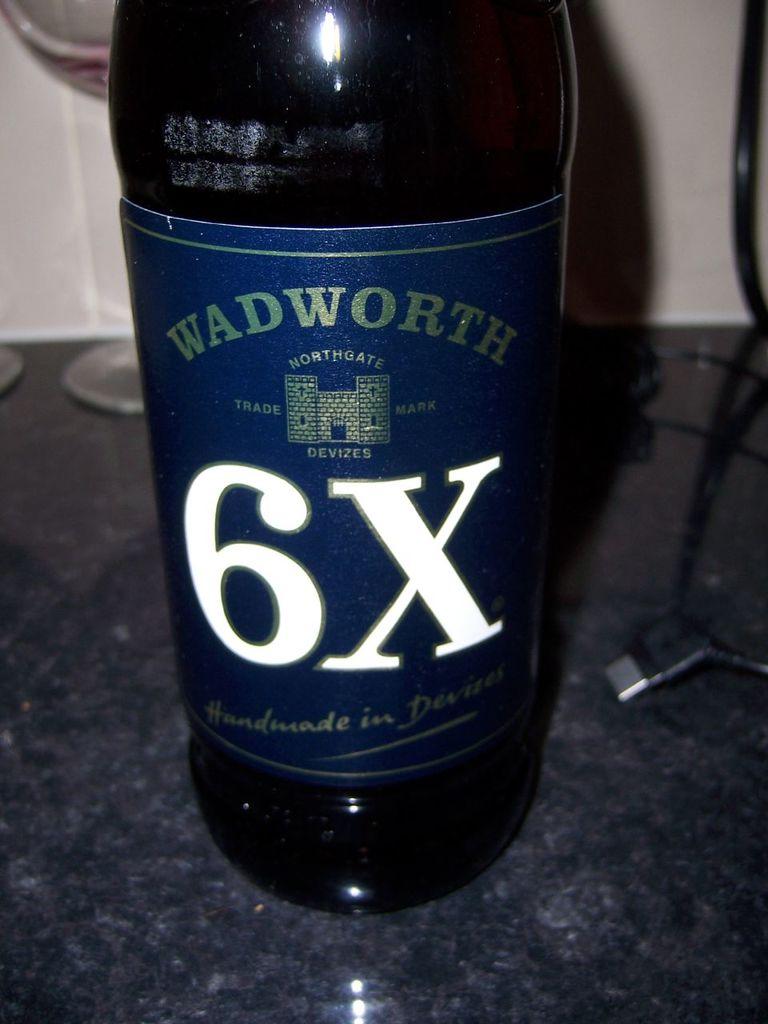In what place was this bottle handmade?
Make the answer very short. Devizes. Does this bottle have an x on it?
Provide a short and direct response. Yes. 